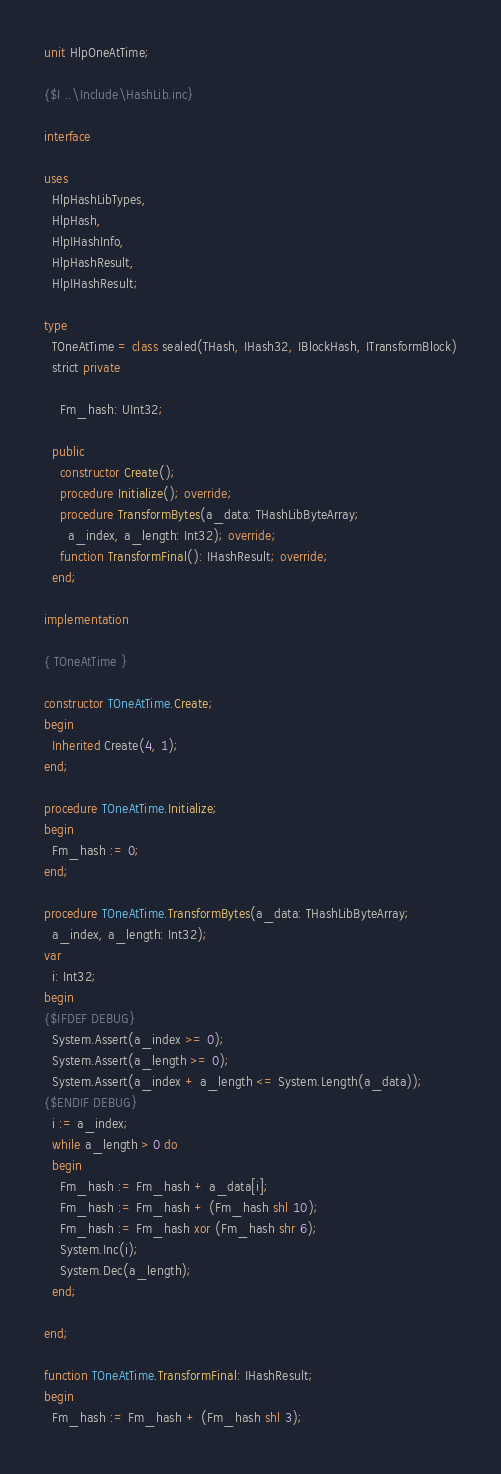Convert code to text. <code><loc_0><loc_0><loc_500><loc_500><_Pascal_>unit HlpOneAtTime;

{$I ..\Include\HashLib.inc}

interface

uses
  HlpHashLibTypes,
  HlpHash,
  HlpIHashInfo,
  HlpHashResult,
  HlpIHashResult;

type
  TOneAtTime = class sealed(THash, IHash32, IBlockHash, ITransformBlock)
  strict private

    Fm_hash: UInt32;

  public
    constructor Create();
    procedure Initialize(); override;
    procedure TransformBytes(a_data: THashLibByteArray;
      a_index, a_length: Int32); override;
    function TransformFinal(): IHashResult; override;
  end;

implementation

{ TOneAtTime }

constructor TOneAtTime.Create;
begin
  Inherited Create(4, 1);
end;

procedure TOneAtTime.Initialize;
begin
  Fm_hash := 0;
end;

procedure TOneAtTime.TransformBytes(a_data: THashLibByteArray;
  a_index, a_length: Int32);
var
  i: Int32;
begin
{$IFDEF DEBUG}
  System.Assert(a_index >= 0);
  System.Assert(a_length >= 0);
  System.Assert(a_index + a_length <= System.Length(a_data));
{$ENDIF DEBUG}
  i := a_index;
  while a_length > 0 do
  begin
    Fm_hash := Fm_hash + a_data[i];
    Fm_hash := Fm_hash + (Fm_hash shl 10);
    Fm_hash := Fm_hash xor (Fm_hash shr 6);
    System.Inc(i);
    System.Dec(a_length);
  end;

end;

function TOneAtTime.TransformFinal: IHashResult;
begin
  Fm_hash := Fm_hash + (Fm_hash shl 3);</code> 